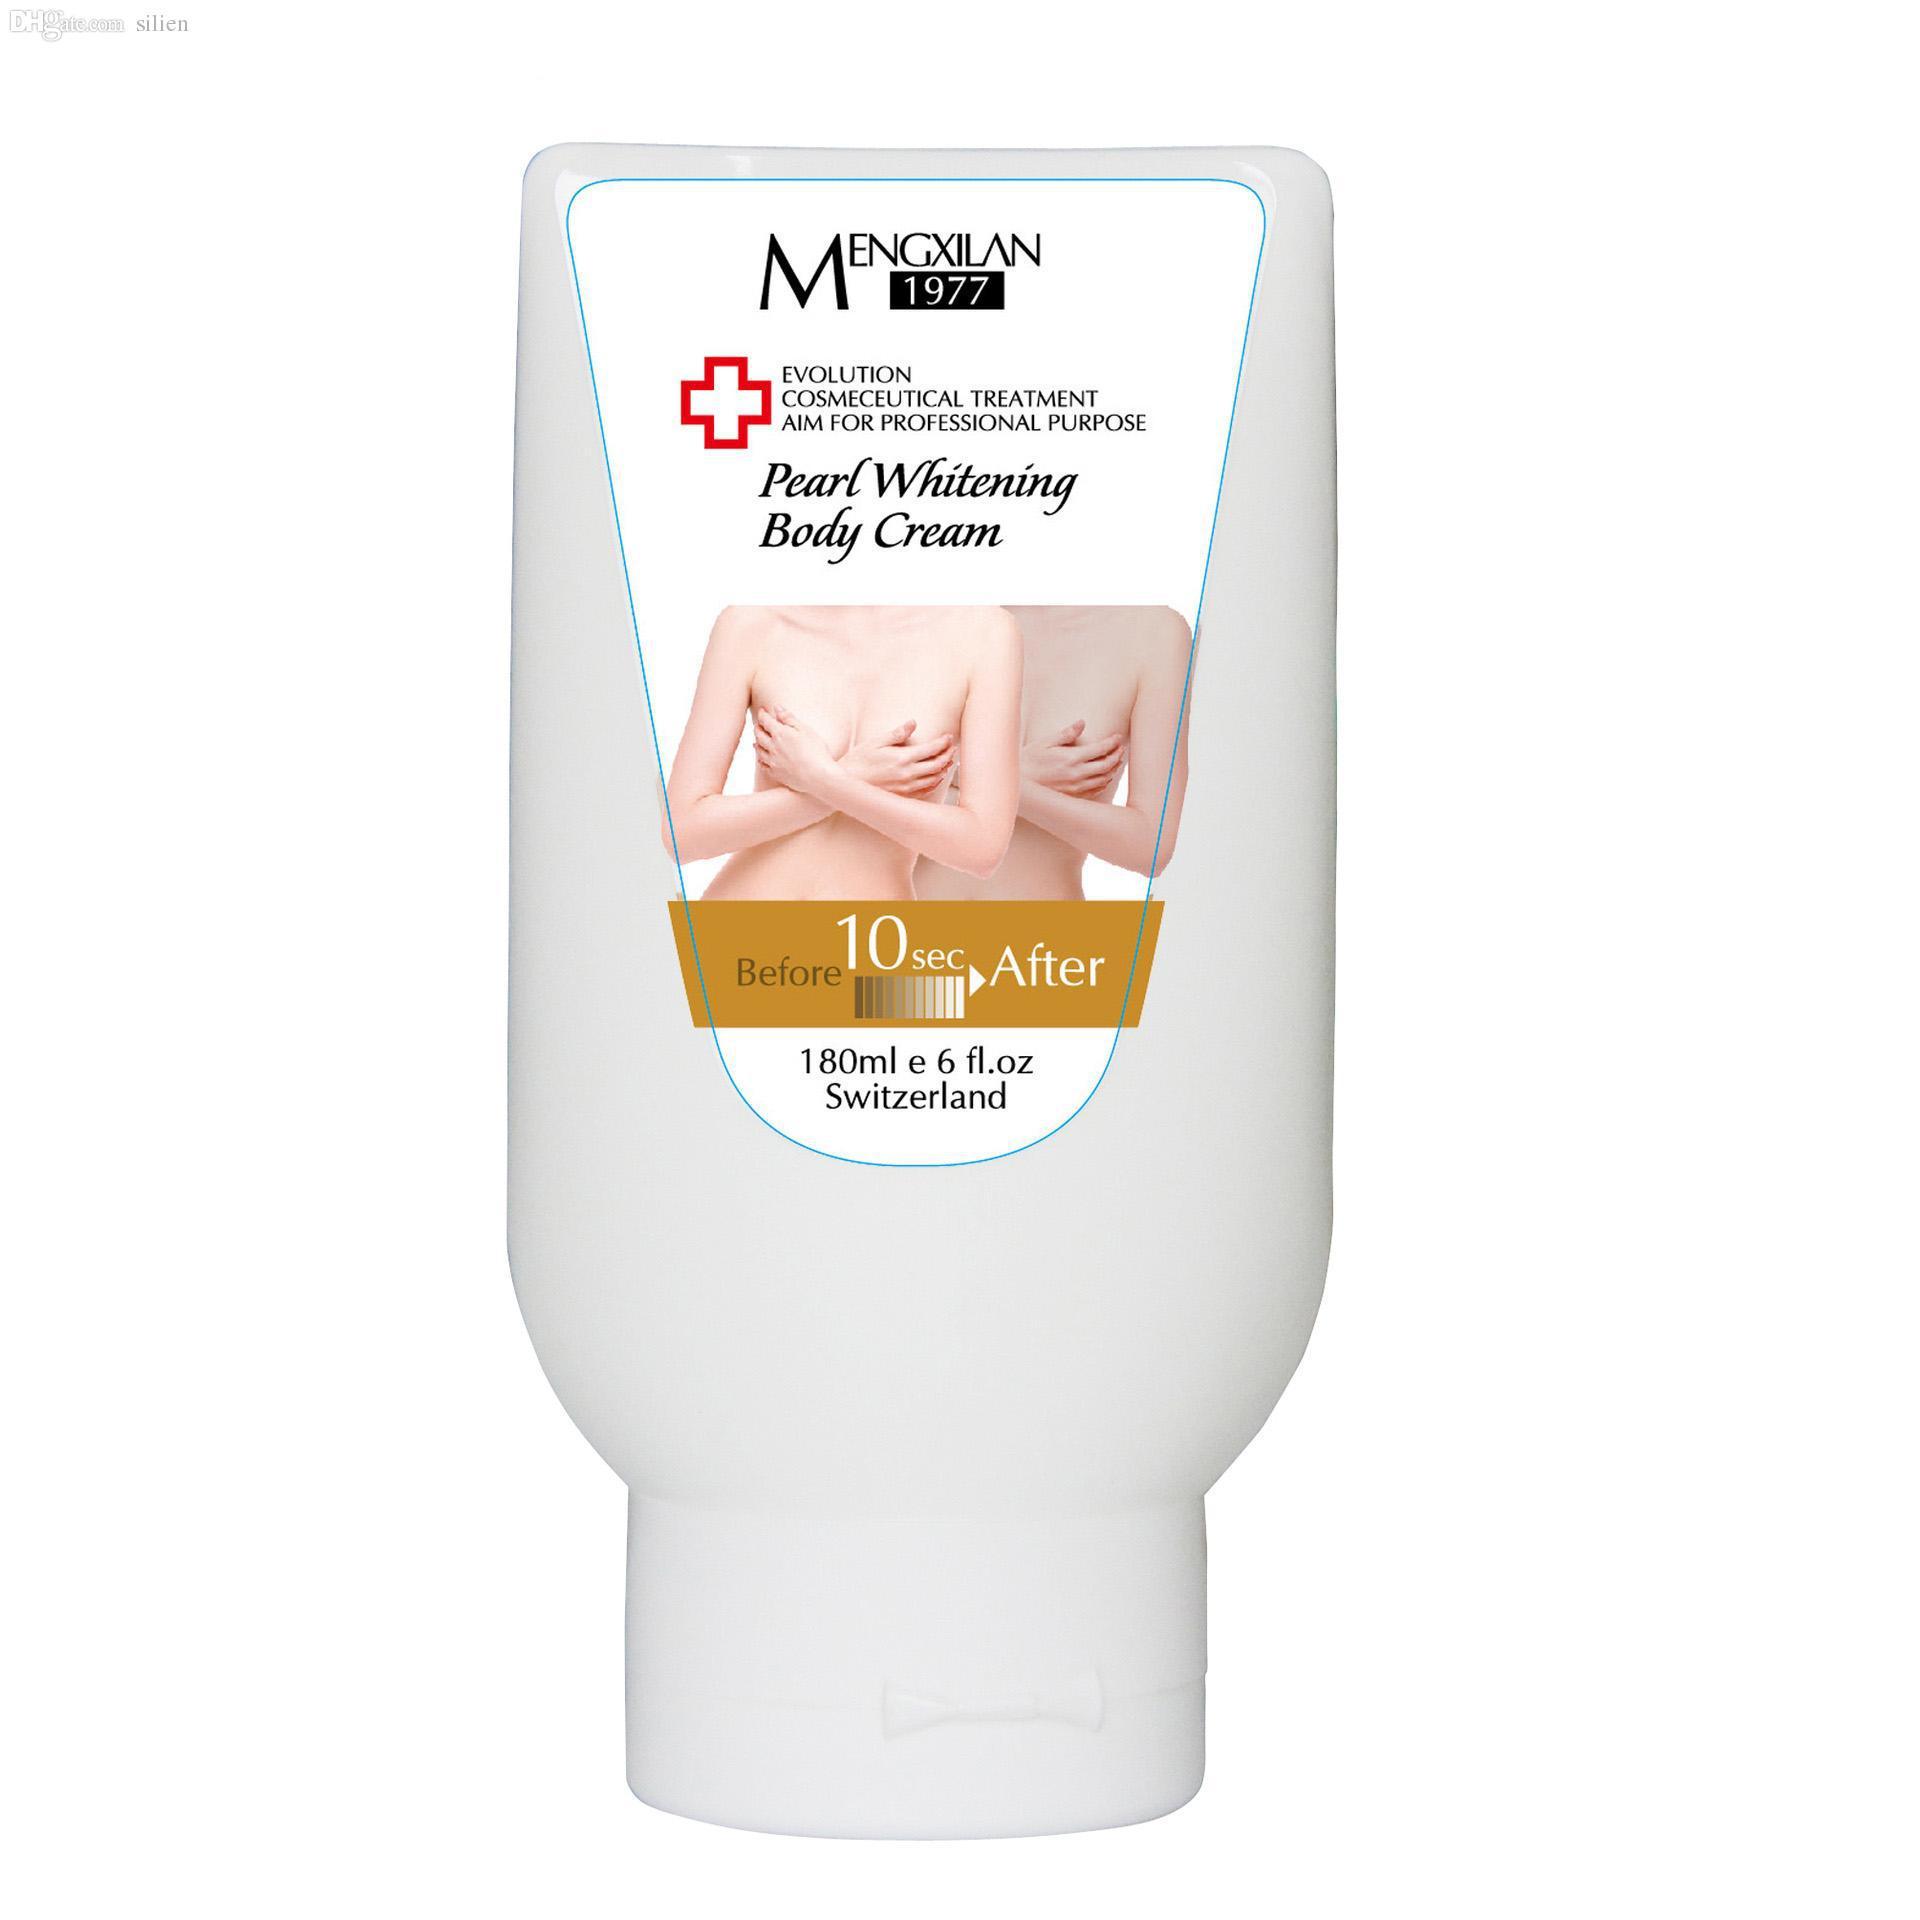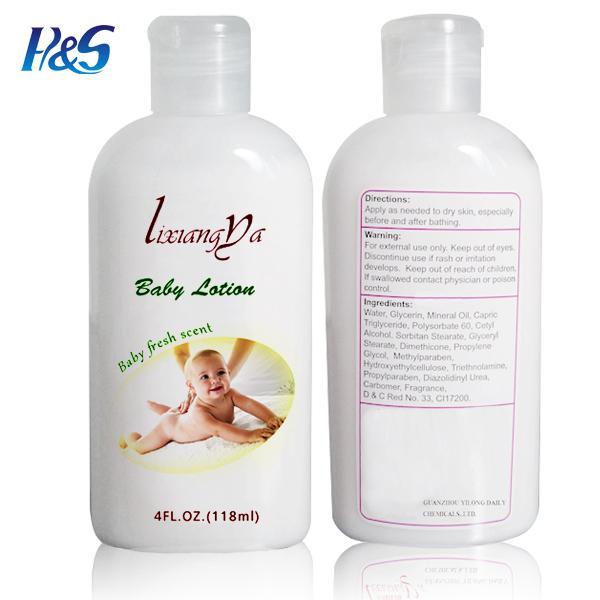The first image is the image on the left, the second image is the image on the right. Assess this claim about the two images: "There are three bottles of lotion.". Correct or not? Answer yes or no. Yes. 